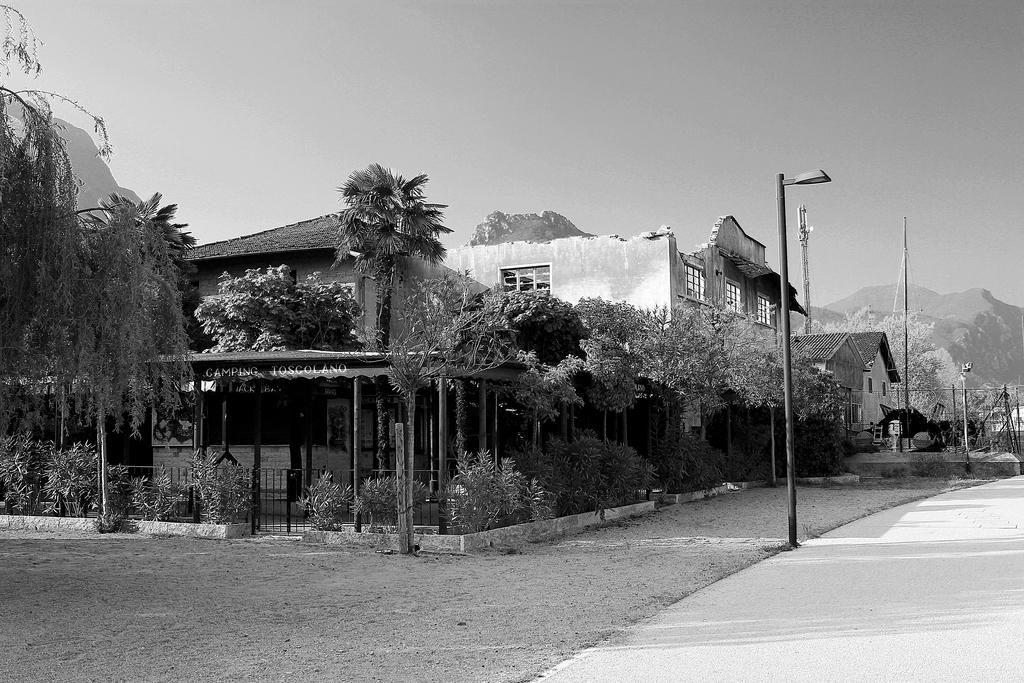What is the color scheme of the image? The image is black and white. What can be seen on the ground in the image? There is a path in the image. What type of structures are present in the image? There are houses in the image. What type of vegetation is present in the image? There are trees and plants in the image. What are the vertical structures in the image? There are poles in the image. What is visible in the background of the image? The sky is visible in the background of the image. How many men are playing net in the image? There are no men or nets present in the image. What day of the week is it in the image? The image does not provide information about the day of the week. 